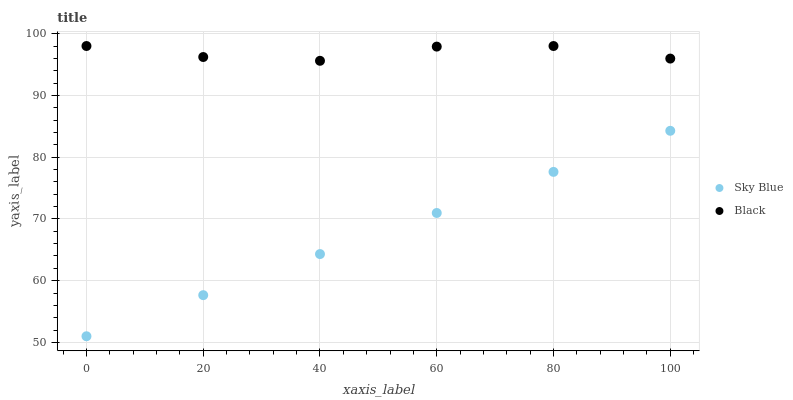Does Sky Blue have the minimum area under the curve?
Answer yes or no. Yes. Does Black have the maximum area under the curve?
Answer yes or no. Yes. Does Black have the minimum area under the curve?
Answer yes or no. No. Is Sky Blue the smoothest?
Answer yes or no. Yes. Is Black the roughest?
Answer yes or no. Yes. Is Black the smoothest?
Answer yes or no. No. Does Sky Blue have the lowest value?
Answer yes or no. Yes. Does Black have the lowest value?
Answer yes or no. No. Does Black have the highest value?
Answer yes or no. Yes. Is Sky Blue less than Black?
Answer yes or no. Yes. Is Black greater than Sky Blue?
Answer yes or no. Yes. Does Sky Blue intersect Black?
Answer yes or no. No. 